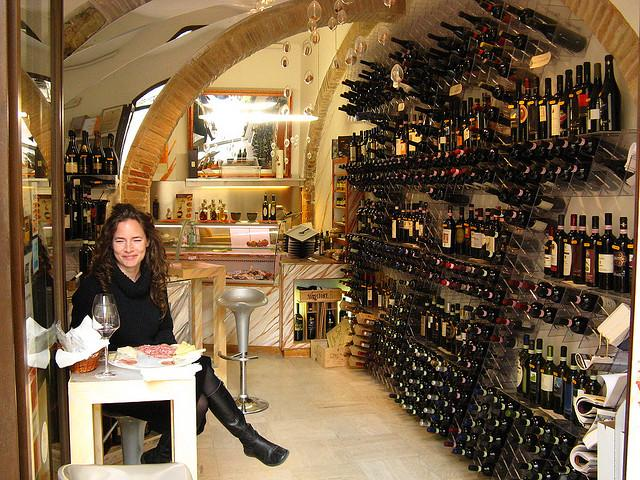What is the woman surrounded by?

Choices:
A) wine bottles
B) elk
C) video games
D) books wine bottles 